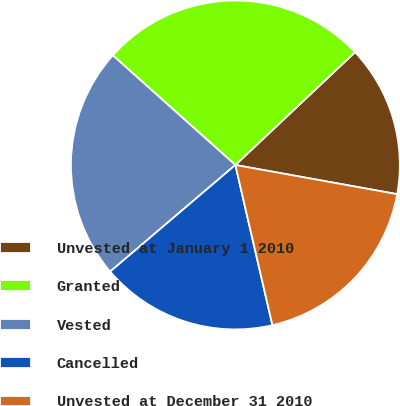<chart> <loc_0><loc_0><loc_500><loc_500><pie_chart><fcel>Unvested at January 1 2010<fcel>Granted<fcel>Vested<fcel>Cancelled<fcel>Unvested at December 31 2010<nl><fcel>14.87%<fcel>26.35%<fcel>22.84%<fcel>17.39%<fcel>18.54%<nl></chart> 